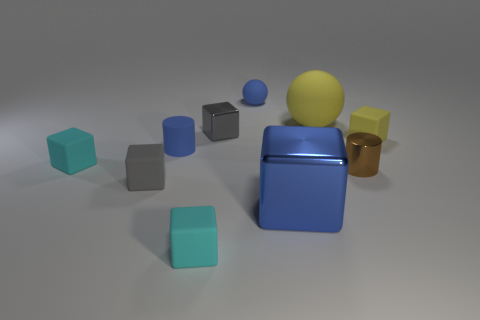Subtract all large cubes. How many cubes are left? 5 Subtract all blue blocks. How many blocks are left? 5 Subtract all red blocks. Subtract all red spheres. How many blocks are left? 6 Subtract all cylinders. How many objects are left? 8 Add 3 shiny things. How many shiny things exist? 6 Subtract 0 purple spheres. How many objects are left? 10 Subtract all tiny blue objects. Subtract all tiny matte things. How many objects are left? 2 Add 6 cyan rubber objects. How many cyan rubber objects are left? 8 